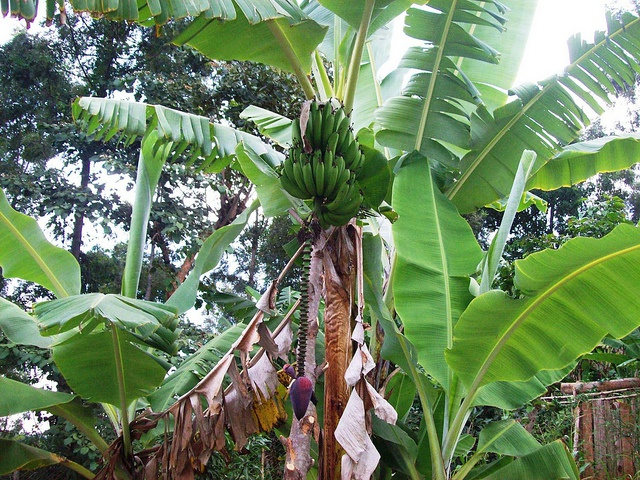Describe the objects in this image and their specific colors. I can see banana in lightblue, darkgreen, black, and green tones and banana in lightblue, darkgreen, black, and green tones in this image. 